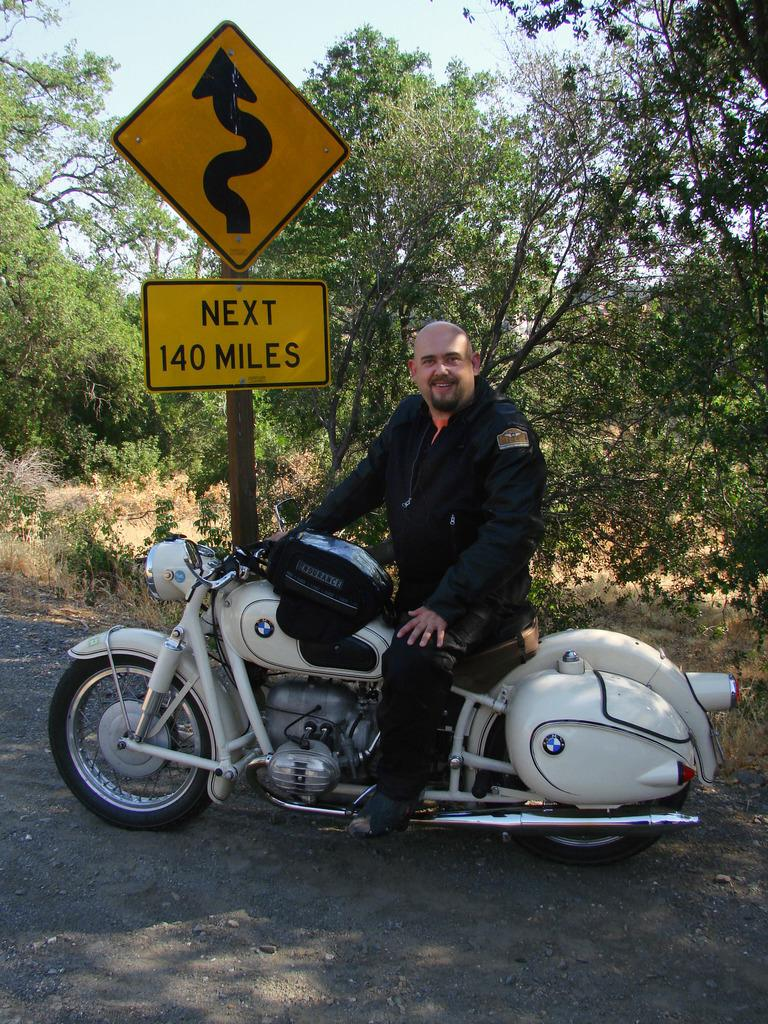Who is present in the image? There is a man in the image. What is the man doing in the image? The man is sitting on a bike and smiling. What can be seen in the background of the image? There is a tree, sky, grass, and a sign board visible in the background of the image. Can you see any earthquakes happening in the image? There is no earthquake present in the image; it shows a man sitting on a bike with a background of a tree, sky, grass, and a sign board. What type of needle is being used by the man in the image? There is no needle present in the image; the man is sitting on a bike and smiling. 